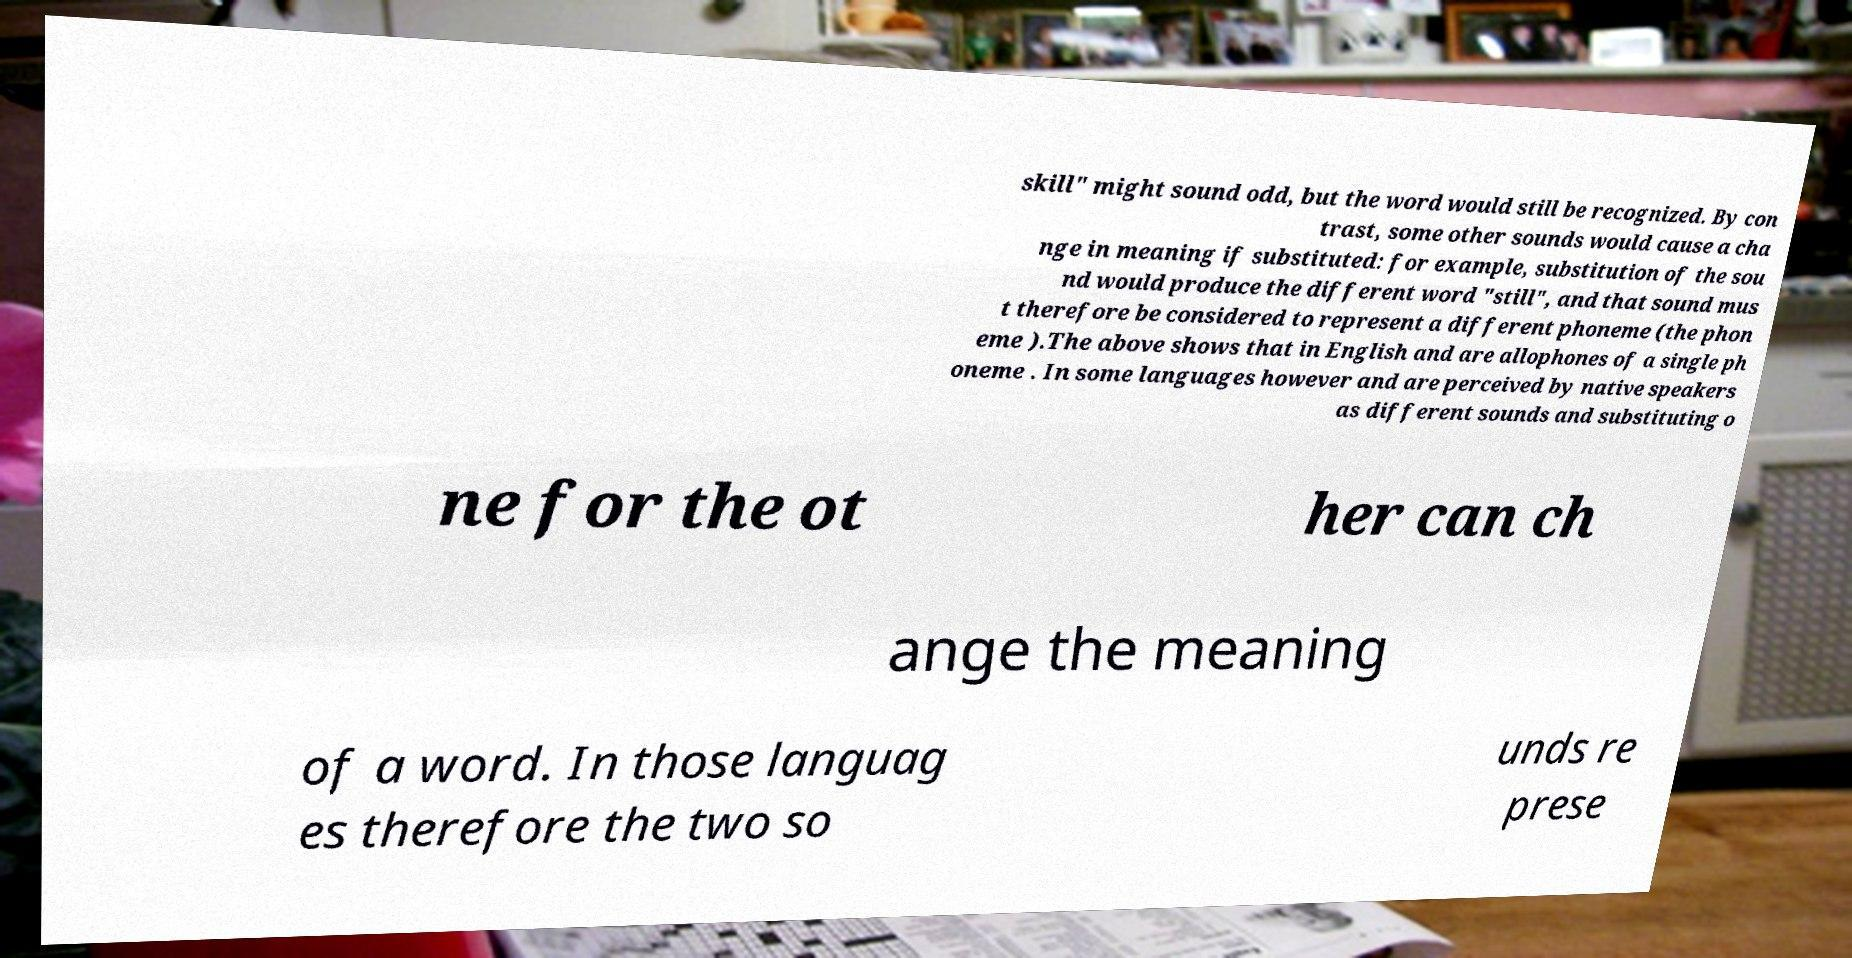Can you read and provide the text displayed in the image?This photo seems to have some interesting text. Can you extract and type it out for me? skill" might sound odd, but the word would still be recognized. By con trast, some other sounds would cause a cha nge in meaning if substituted: for example, substitution of the sou nd would produce the different word "still", and that sound mus t therefore be considered to represent a different phoneme (the phon eme ).The above shows that in English and are allophones of a single ph oneme . In some languages however and are perceived by native speakers as different sounds and substituting o ne for the ot her can ch ange the meaning of a word. In those languag es therefore the two so unds re prese 